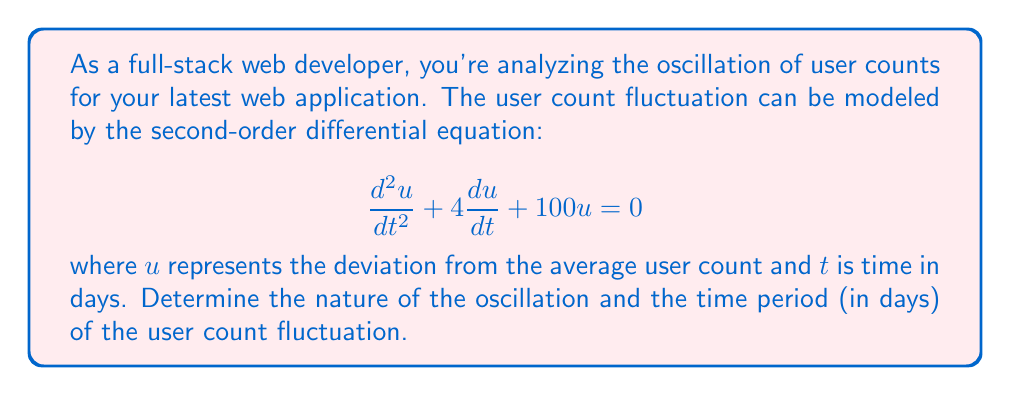Can you solve this math problem? To analyze this second-order linear equation, we'll follow these steps:

1) The general form of a second-order linear equation is:
   $$\frac{d^2u}{dt^2} + 2\zeta\omega_n\frac{du}{dt} + \omega_n^2u = 0$$
   where $\zeta$ is the damping ratio and $\omega_n$ is the natural frequency.

2) Comparing our equation to the general form:
   $$\frac{d^2u}{dt^2} + 4\frac{du}{dt} + 100u = 0$$
   We can identify that $2\zeta\omega_n = 4$ and $\omega_n^2 = 100$.

3) From $\omega_n^2 = 100$, we can determine $\omega_n = 10$ rad/day.

4) Now we can find $\zeta$:
   $2\zeta\omega_n = 4$
   $2\zeta(10) = 4$
   $\zeta = 0.2$

5) Since $0 < \zeta < 1$, this system is underdamped, meaning it will oscillate with decreasing amplitude.

6) For an underdamped system, the damped natural frequency is:
   $$\omega_d = \omega_n\sqrt{1-\zeta^2}$$
   $$\omega_d = 10\sqrt{1-0.2^2} = 9.798 \text{ rad/day}$$

7) The time period of oscillation is:
   $$T = \frac{2\pi}{\omega_d} = \frac{2\pi}{9.798} = 0.6413 \text{ days}$$

This means the user count will oscillate with a period of approximately 0.6413 days or about 15.39 hours.
Answer: The user count exhibits underdamped oscillation with a time period of 0.6413 days. 